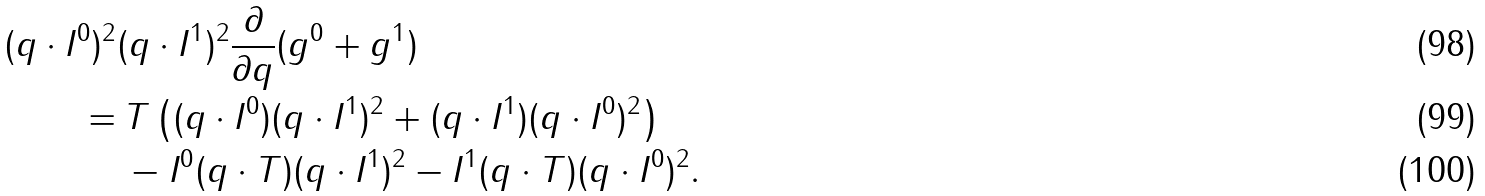<formula> <loc_0><loc_0><loc_500><loc_500>( q \cdot I ^ { 0 } ) ^ { 2 } & ( q \cdot I ^ { 1 } ) ^ { 2 } \frac { \partial } { \partial q } ( g ^ { 0 } + g ^ { 1 } ) \\ = & \, T \left ( ( q \cdot I ^ { 0 } ) ( q \cdot I ^ { 1 } ) ^ { 2 } + ( q \cdot I ^ { 1 } ) ( q \cdot I ^ { 0 } ) ^ { 2 } \right ) \\ & \, - I ^ { 0 } ( q \cdot T ) ( q \cdot I ^ { 1 } ) ^ { 2 } - I ^ { 1 } ( q \cdot T ) ( q \cdot I ^ { 0 } ) ^ { 2 } .</formula> 